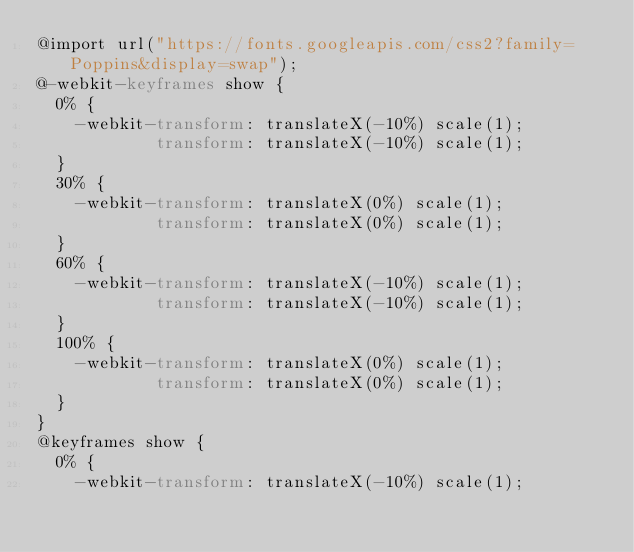<code> <loc_0><loc_0><loc_500><loc_500><_CSS_>@import url("https://fonts.googleapis.com/css2?family=Poppins&display=swap");
@-webkit-keyframes show {
  0% {
    -webkit-transform: translateX(-10%) scale(1);
            transform: translateX(-10%) scale(1);
  }
  30% {
    -webkit-transform: translateX(0%) scale(1);
            transform: translateX(0%) scale(1);
  }
  60% {
    -webkit-transform: translateX(-10%) scale(1);
            transform: translateX(-10%) scale(1);
  }
  100% {
    -webkit-transform: translateX(0%) scale(1);
            transform: translateX(0%) scale(1);
  }
}
@keyframes show {
  0% {
    -webkit-transform: translateX(-10%) scale(1);</code> 